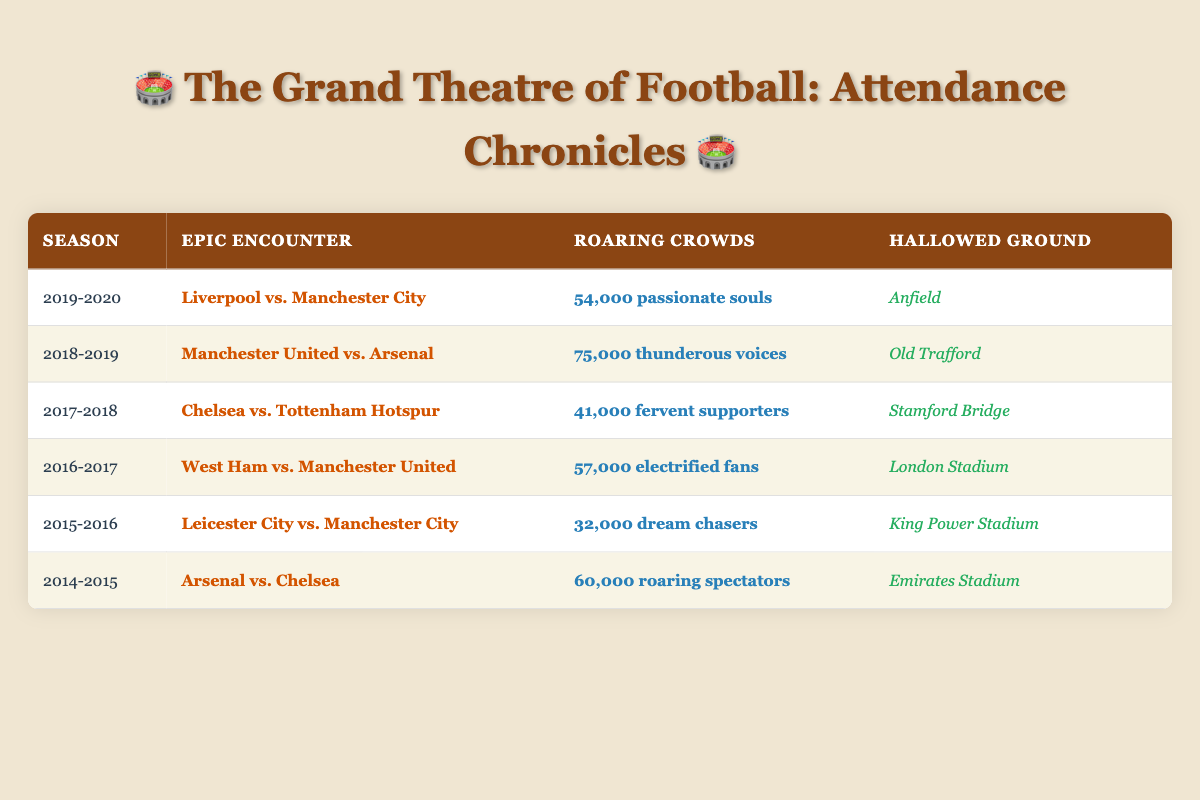What was the match with the highest attendance? The match with the highest attendance can be found by comparing the values in the "Roaring Crowds" column. The highest value is 75,000 for the match "Manchester United vs. Arsenal" in the 2018-2019 season.
Answer: Manchester United vs. Arsenal What is the average attendance across all matches listed? To find the average attendance, we first sum all attendance figures: 54,000 + 75,000 + 41,000 + 57,000 + 32,000 + 60,000 = 319,000. There are 6 matches, so we divide the sum by 6: 319,000 / 6 = 53,166.67. Therefore, the average attendance is approximately 53,167.
Answer: 53,167 Did more than 60,000 fans attend a match in the 2019-2020 season? Looking at the attendance for the 2019-2020 season, the match "Liverpool vs. Manchester City" had an attendance of 54,000, which is less than 60,000. Thus, no match exceeded 60,000 fans that season.
Answer: No Which two venues had the closest attendance figures? By examining the "Roaring Crowds" column, we see the attendances were 54,000 (Anfield) vs 57,000 (London Stadium), and 41,000 (Stamford Bridge) vs 32,000 (King Power Stadium). The closest pair is 54,000 and 57,000, with a difference of 3,000.
Answer: Anfield and London Stadium What percentage of the total attendance did the match in the 2015-2016 season represent? First, we find the total attendance by summing all figures: 319,000, as calculated before. The match in the 2015-2016 season had 32,000 attendees. To find the percentage, we use the formula: (32,000 / 319,000) * 100 = 10.03%. So, it represents approximately 10% of the total attendance.
Answer: 10% 